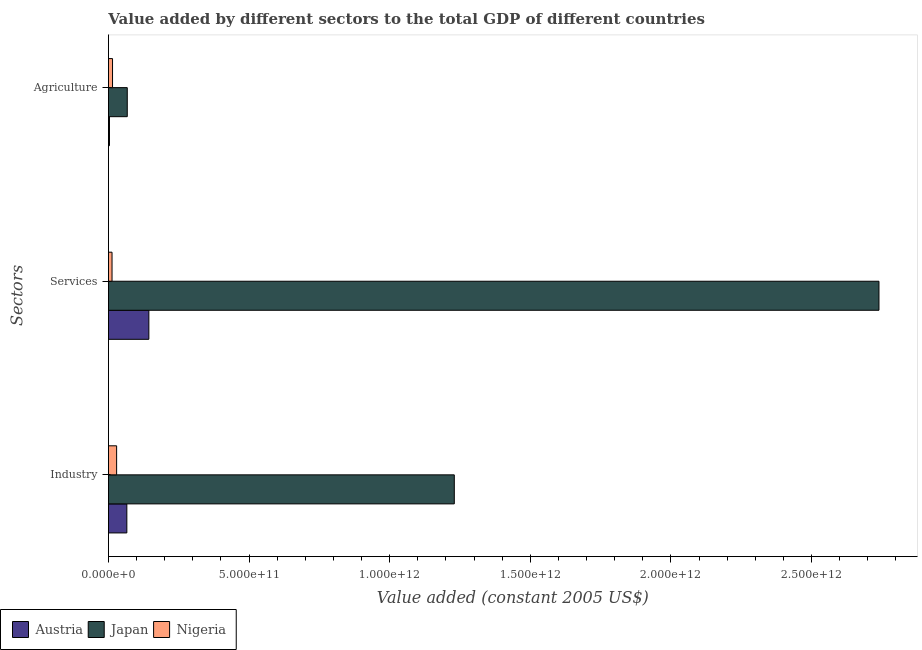Are the number of bars on each tick of the Y-axis equal?
Offer a very short reply. Yes. What is the label of the 1st group of bars from the top?
Ensure brevity in your answer.  Agriculture. What is the value added by industrial sector in Austria?
Provide a short and direct response. 6.55e+1. Across all countries, what is the maximum value added by industrial sector?
Your answer should be very brief. 1.23e+12. Across all countries, what is the minimum value added by agricultural sector?
Give a very brief answer. 3.71e+09. In which country was the value added by agricultural sector maximum?
Offer a very short reply. Japan. In which country was the value added by agricultural sector minimum?
Your answer should be compact. Austria. What is the total value added by industrial sector in the graph?
Your answer should be very brief. 1.32e+12. What is the difference between the value added by services in Japan and that in Austria?
Your answer should be very brief. 2.60e+12. What is the difference between the value added by agricultural sector in Japan and the value added by services in Nigeria?
Your answer should be compact. 5.41e+1. What is the average value added by agricultural sector per country?
Keep it short and to the point. 2.84e+1. What is the difference between the value added by services and value added by agricultural sector in Japan?
Make the answer very short. 2.67e+12. What is the ratio of the value added by agricultural sector in Nigeria to that in Austria?
Your answer should be compact. 3.94. Is the value added by services in Austria less than that in Japan?
Offer a terse response. Yes. Is the difference between the value added by agricultural sector in Japan and Austria greater than the difference between the value added by industrial sector in Japan and Austria?
Make the answer very short. No. What is the difference between the highest and the second highest value added by agricultural sector?
Give a very brief answer. 5.24e+1. What is the difference between the highest and the lowest value added by services?
Ensure brevity in your answer.  2.73e+12. In how many countries, is the value added by agricultural sector greater than the average value added by agricultural sector taken over all countries?
Give a very brief answer. 1. Is the sum of the value added by services in Austria and Japan greater than the maximum value added by agricultural sector across all countries?
Offer a terse response. Yes. What does the 3rd bar from the bottom in Agriculture represents?
Ensure brevity in your answer.  Nigeria. Is it the case that in every country, the sum of the value added by industrial sector and value added by services is greater than the value added by agricultural sector?
Provide a short and direct response. Yes. How many bars are there?
Provide a short and direct response. 9. What is the difference between two consecutive major ticks on the X-axis?
Provide a short and direct response. 5.00e+11. Are the values on the major ticks of X-axis written in scientific E-notation?
Provide a succinct answer. Yes. Does the graph contain any zero values?
Provide a short and direct response. No. Does the graph contain grids?
Your answer should be compact. No. Where does the legend appear in the graph?
Your response must be concise. Bottom left. What is the title of the graph?
Your response must be concise. Value added by different sectors to the total GDP of different countries. Does "Korea (Republic)" appear as one of the legend labels in the graph?
Your response must be concise. No. What is the label or title of the X-axis?
Provide a succinct answer. Value added (constant 2005 US$). What is the label or title of the Y-axis?
Offer a terse response. Sectors. What is the Value added (constant 2005 US$) of Austria in Industry?
Provide a succinct answer. 6.55e+1. What is the Value added (constant 2005 US$) in Japan in Industry?
Keep it short and to the point. 1.23e+12. What is the Value added (constant 2005 US$) in Nigeria in Industry?
Offer a very short reply. 2.91e+1. What is the Value added (constant 2005 US$) in Austria in Services?
Provide a short and direct response. 1.44e+11. What is the Value added (constant 2005 US$) of Japan in Services?
Provide a succinct answer. 2.74e+12. What is the Value added (constant 2005 US$) of Nigeria in Services?
Your answer should be very brief. 1.28e+1. What is the Value added (constant 2005 US$) in Austria in Agriculture?
Make the answer very short. 3.71e+09. What is the Value added (constant 2005 US$) in Japan in Agriculture?
Ensure brevity in your answer.  6.69e+1. What is the Value added (constant 2005 US$) of Nigeria in Agriculture?
Ensure brevity in your answer.  1.46e+1. Across all Sectors, what is the maximum Value added (constant 2005 US$) of Austria?
Your response must be concise. 1.44e+11. Across all Sectors, what is the maximum Value added (constant 2005 US$) in Japan?
Offer a terse response. 2.74e+12. Across all Sectors, what is the maximum Value added (constant 2005 US$) of Nigeria?
Provide a short and direct response. 2.91e+1. Across all Sectors, what is the minimum Value added (constant 2005 US$) in Austria?
Provide a succinct answer. 3.71e+09. Across all Sectors, what is the minimum Value added (constant 2005 US$) of Japan?
Ensure brevity in your answer.  6.69e+1. Across all Sectors, what is the minimum Value added (constant 2005 US$) of Nigeria?
Make the answer very short. 1.28e+1. What is the total Value added (constant 2005 US$) of Austria in the graph?
Make the answer very short. 2.13e+11. What is the total Value added (constant 2005 US$) in Japan in the graph?
Ensure brevity in your answer.  4.04e+12. What is the total Value added (constant 2005 US$) in Nigeria in the graph?
Offer a terse response. 5.65e+1. What is the difference between the Value added (constant 2005 US$) of Austria in Industry and that in Services?
Provide a short and direct response. -7.83e+1. What is the difference between the Value added (constant 2005 US$) in Japan in Industry and that in Services?
Provide a short and direct response. -1.51e+12. What is the difference between the Value added (constant 2005 US$) in Nigeria in Industry and that in Services?
Provide a succinct answer. 1.63e+1. What is the difference between the Value added (constant 2005 US$) in Austria in Industry and that in Agriculture?
Offer a very short reply. 6.18e+1. What is the difference between the Value added (constant 2005 US$) in Japan in Industry and that in Agriculture?
Give a very brief answer. 1.16e+12. What is the difference between the Value added (constant 2005 US$) of Nigeria in Industry and that in Agriculture?
Make the answer very short. 1.45e+1. What is the difference between the Value added (constant 2005 US$) of Austria in Services and that in Agriculture?
Your response must be concise. 1.40e+11. What is the difference between the Value added (constant 2005 US$) of Japan in Services and that in Agriculture?
Your answer should be compact. 2.67e+12. What is the difference between the Value added (constant 2005 US$) of Nigeria in Services and that in Agriculture?
Your answer should be compact. -1.77e+09. What is the difference between the Value added (constant 2005 US$) of Austria in Industry and the Value added (constant 2005 US$) of Japan in Services?
Your answer should be very brief. -2.67e+12. What is the difference between the Value added (constant 2005 US$) of Austria in Industry and the Value added (constant 2005 US$) of Nigeria in Services?
Make the answer very short. 5.27e+1. What is the difference between the Value added (constant 2005 US$) in Japan in Industry and the Value added (constant 2005 US$) in Nigeria in Services?
Offer a very short reply. 1.22e+12. What is the difference between the Value added (constant 2005 US$) in Austria in Industry and the Value added (constant 2005 US$) in Japan in Agriculture?
Give a very brief answer. -1.48e+09. What is the difference between the Value added (constant 2005 US$) of Austria in Industry and the Value added (constant 2005 US$) of Nigeria in Agriculture?
Your response must be concise. 5.09e+1. What is the difference between the Value added (constant 2005 US$) in Japan in Industry and the Value added (constant 2005 US$) in Nigeria in Agriculture?
Provide a short and direct response. 1.22e+12. What is the difference between the Value added (constant 2005 US$) of Austria in Services and the Value added (constant 2005 US$) of Japan in Agriculture?
Give a very brief answer. 7.68e+1. What is the difference between the Value added (constant 2005 US$) of Austria in Services and the Value added (constant 2005 US$) of Nigeria in Agriculture?
Your answer should be very brief. 1.29e+11. What is the difference between the Value added (constant 2005 US$) of Japan in Services and the Value added (constant 2005 US$) of Nigeria in Agriculture?
Provide a succinct answer. 2.73e+12. What is the average Value added (constant 2005 US$) in Austria per Sectors?
Offer a terse response. 7.10e+1. What is the average Value added (constant 2005 US$) in Japan per Sectors?
Provide a succinct answer. 1.35e+12. What is the average Value added (constant 2005 US$) in Nigeria per Sectors?
Keep it short and to the point. 1.88e+1. What is the difference between the Value added (constant 2005 US$) of Austria and Value added (constant 2005 US$) of Japan in Industry?
Ensure brevity in your answer.  -1.16e+12. What is the difference between the Value added (constant 2005 US$) in Austria and Value added (constant 2005 US$) in Nigeria in Industry?
Your response must be concise. 3.63e+1. What is the difference between the Value added (constant 2005 US$) of Japan and Value added (constant 2005 US$) of Nigeria in Industry?
Keep it short and to the point. 1.20e+12. What is the difference between the Value added (constant 2005 US$) of Austria and Value added (constant 2005 US$) of Japan in Services?
Your answer should be very brief. -2.60e+12. What is the difference between the Value added (constant 2005 US$) of Austria and Value added (constant 2005 US$) of Nigeria in Services?
Give a very brief answer. 1.31e+11. What is the difference between the Value added (constant 2005 US$) in Japan and Value added (constant 2005 US$) in Nigeria in Services?
Offer a very short reply. 2.73e+12. What is the difference between the Value added (constant 2005 US$) in Austria and Value added (constant 2005 US$) in Japan in Agriculture?
Offer a terse response. -6.32e+1. What is the difference between the Value added (constant 2005 US$) of Austria and Value added (constant 2005 US$) of Nigeria in Agriculture?
Your answer should be compact. -1.09e+1. What is the difference between the Value added (constant 2005 US$) in Japan and Value added (constant 2005 US$) in Nigeria in Agriculture?
Offer a terse response. 5.24e+1. What is the ratio of the Value added (constant 2005 US$) of Austria in Industry to that in Services?
Make the answer very short. 0.46. What is the ratio of the Value added (constant 2005 US$) in Japan in Industry to that in Services?
Your answer should be very brief. 0.45. What is the ratio of the Value added (constant 2005 US$) in Nigeria in Industry to that in Services?
Make the answer very short. 2.27. What is the ratio of the Value added (constant 2005 US$) of Austria in Industry to that in Agriculture?
Make the answer very short. 17.67. What is the ratio of the Value added (constant 2005 US$) in Japan in Industry to that in Agriculture?
Provide a short and direct response. 18.37. What is the ratio of the Value added (constant 2005 US$) in Nigeria in Industry to that in Agriculture?
Keep it short and to the point. 2. What is the ratio of the Value added (constant 2005 US$) of Austria in Services to that in Agriculture?
Provide a succinct answer. 38.8. What is the ratio of the Value added (constant 2005 US$) in Japan in Services to that in Agriculture?
Offer a terse response. 40.92. What is the ratio of the Value added (constant 2005 US$) of Nigeria in Services to that in Agriculture?
Make the answer very short. 0.88. What is the difference between the highest and the second highest Value added (constant 2005 US$) of Austria?
Offer a terse response. 7.83e+1. What is the difference between the highest and the second highest Value added (constant 2005 US$) of Japan?
Keep it short and to the point. 1.51e+12. What is the difference between the highest and the second highest Value added (constant 2005 US$) of Nigeria?
Ensure brevity in your answer.  1.45e+1. What is the difference between the highest and the lowest Value added (constant 2005 US$) in Austria?
Offer a terse response. 1.40e+11. What is the difference between the highest and the lowest Value added (constant 2005 US$) in Japan?
Your response must be concise. 2.67e+12. What is the difference between the highest and the lowest Value added (constant 2005 US$) of Nigeria?
Your answer should be very brief. 1.63e+1. 